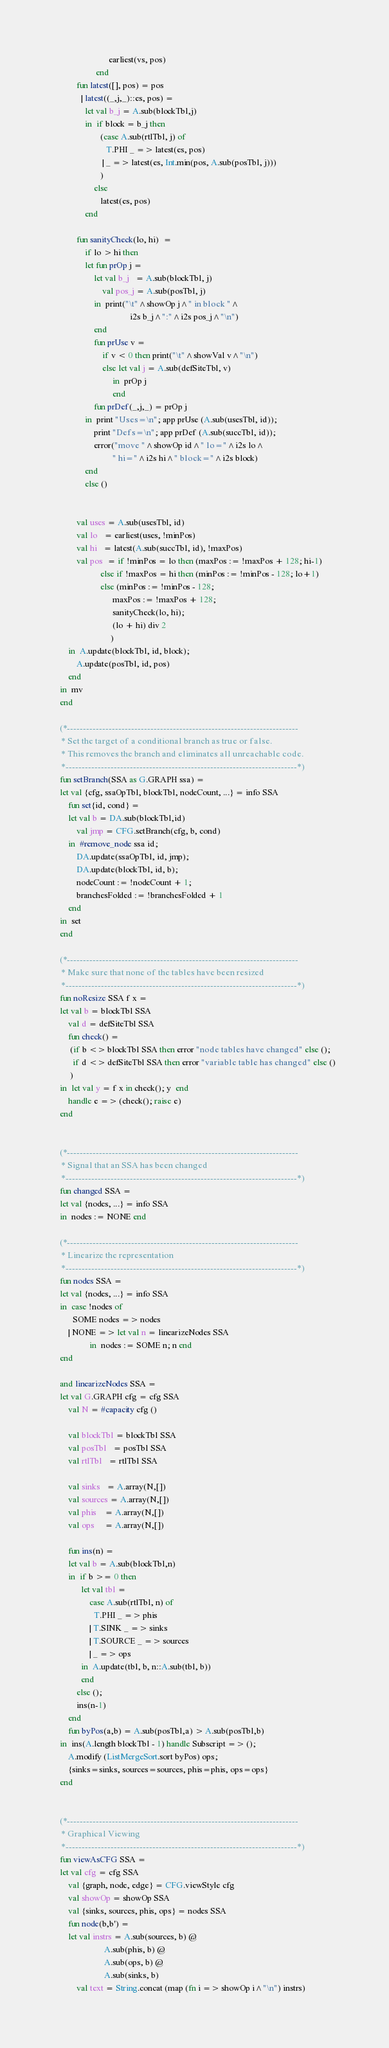<code> <loc_0><loc_0><loc_500><loc_500><_SML_>                          earliest(vs, pos)
                    end
           fun latest([], pos) = pos
             | latest((_,j,_)::es, pos) =
               let val b_j = A.sub(blockTbl,j)
               in  if block = b_j then
                      (case A.sub(rtlTbl, j) of
                         T.PHI _ => latest(es, pos)
                       | _ => latest(es, Int.min(pos, A.sub(posTbl, j)))
                      )
                   else
                      latest(es, pos)
               end

           fun sanityCheck(lo, hi)  =
               if lo > hi then
               let fun prOp j =
                   let val b_j   = A.sub(blockTbl, j)
                       val pos_j = A.sub(posTbl, j)
                   in  print("\t"^showOp j^" in block "^
                                    i2s b_j^":"^i2s pos_j^"\n")
                   end
                   fun prUse v = 
                       if v < 0 then print("\t"^showVal v^"\n")
                       else let val j = A.sub(defSiteTbl, v)
                            in  prOp j
                            end
                   fun prDef(_,j,_) = prOp j
               in  print "Uses=\n"; app prUse (A.sub(usesTbl, id));
                   print "Defs=\n"; app prDef (A.sub(succTbl, id));
                   error("move "^showOp id^" lo="^i2s lo^
                            " hi="^i2s hi^" block="^i2s block)
               end 
               else ()


           val uses = A.sub(usesTbl, id)
           val lo   = earliest(uses, !minPos)
           val hi   = latest(A.sub(succTbl, id), !maxPos)
           val pos  = if !minPos = lo then (maxPos := !maxPos + 128; hi-1)
                      else if !maxPos = hi then (minPos := !minPos - 128; lo+1)
                      else (minPos := !minPos - 128; 
                            maxPos := !maxPos + 128;
                            sanityCheck(lo, hi);
                            (lo + hi) div 2
                           )
       in  A.update(blockTbl, id, block);
           A.update(posTbl, id, pos)
       end
   in  mv
   end

   (*------------------------------------------------------------------------
    * Set the target of a conditional branch as true or false.
    * This removes the branch and eliminates all unreachable code.
    *------------------------------------------------------------------------*)
   fun setBranch(SSA as G.GRAPH ssa) =
   let val {cfg, ssaOpTbl, blockTbl, nodeCount, ...} = info SSA
       fun set{id, cond} = 
       let val b = DA.sub(blockTbl,id)
           val jmp = CFG.setBranch(cfg, b, cond)
       in  #remove_node ssa id;
           DA.update(ssaOpTbl, id, jmp);
           DA.update(blockTbl, id, b);
           nodeCount := !nodeCount + 1;
           branchesFolded := !branchesFolded + 1
       end
   in  set 
   end

   (*------------------------------------------------------------------------
    * Make sure that none of the tables have been resized
    *------------------------------------------------------------------------*)
   fun noResize SSA f x =
   let val b = blockTbl SSA
       val d = defSiteTbl SSA
       fun check() =
        (if b <> blockTbl SSA then error "node tables have changed" else ();
         if d <> defSiteTbl SSA then error "variable table has changed" else ()
        )
   in  let val y = f x in check(); y  end
       handle e => (check(); raise e)
   end
    

   (*------------------------------------------------------------------------
    * Signal that an SSA has been changed
    *------------------------------------------------------------------------*)
   fun changed SSA = 
   let val {nodes, ...} = info SSA
   in  nodes := NONE end

   (*------------------------------------------------------------------------
    * Linearize the representation
    *------------------------------------------------------------------------*)
   fun nodes SSA =
   let val {nodes, ...} = info SSA
   in  case !nodes of
         SOME nodes => nodes
       | NONE => let val n = linearizeNodes SSA
                 in  nodes := SOME n; n end
   end

   and linearizeNodes SSA = 
   let val G.GRAPH cfg = cfg SSA
       val N = #capacity cfg ()

       val blockTbl = blockTbl SSA
       val posTbl   = posTbl SSA
       val rtlTbl   = rtlTbl SSA

       val sinks   = A.array(N,[])
       val sources = A.array(N,[])
       val phis    = A.array(N,[])
       val ops     = A.array(N,[]) 

       fun ins(n) = 
       let val b = A.sub(blockTbl,n) 
       in  if b >= 0 then
             let val tbl = 
                 case A.sub(rtlTbl, n) of
                   T.PHI _ => phis
                 | T.SINK _ => sinks
                 | T.SOURCE _ => sources
                 | _ => ops
             in  A.update(tbl, b, n::A.sub(tbl, b))
             end
           else ();
           ins(n-1)
       end
       fun byPos(a,b) = A.sub(posTbl,a) > A.sub(posTbl,b)
   in  ins(A.length blockTbl - 1) handle Subscript => ();
       A.modify (ListMergeSort.sort byPos) ops;
       {sinks=sinks, sources=sources, phis=phis, ops=ops}
   end


   (*------------------------------------------------------------------------
    * Graphical Viewing
    *------------------------------------------------------------------------*)
   fun viewAsCFG SSA = 
   let val cfg = cfg SSA
       val {graph, node, edge} = CFG.viewStyle cfg
       val showOp = showOp SSA
       val {sinks, sources, phis, ops} = nodes SSA
       fun node(b,b') = 
       let val instrs = A.sub(sources, b) @ 
                        A.sub(phis, b) @
                        A.sub(ops, b) @
                        A.sub(sinks, b) 
           val text = String.concat (map (fn i => showOp i^"\n") instrs)</code> 